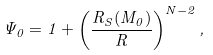<formula> <loc_0><loc_0><loc_500><loc_500>\Psi _ { 0 } = 1 + \left ( \frac { R _ { S } ( M _ { 0 } ) } { R } \right ) ^ { N - 2 } ,</formula> 